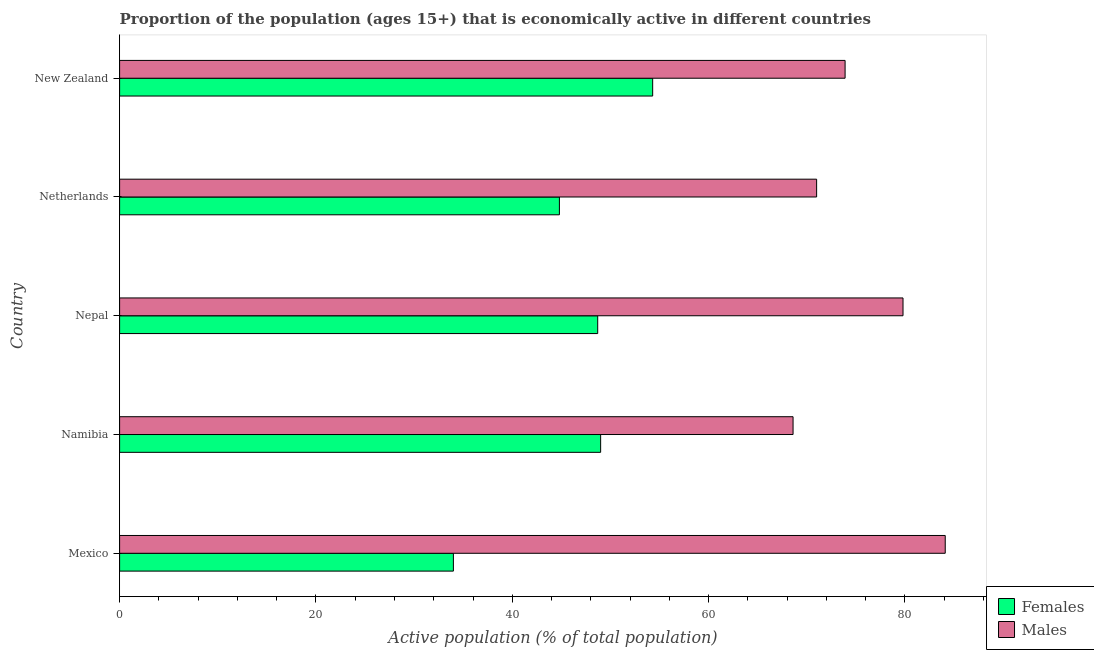How many different coloured bars are there?
Give a very brief answer. 2. Are the number of bars per tick equal to the number of legend labels?
Your answer should be very brief. Yes. Are the number of bars on each tick of the Y-axis equal?
Provide a short and direct response. Yes. How many bars are there on the 2nd tick from the top?
Provide a succinct answer. 2. What is the label of the 4th group of bars from the top?
Provide a succinct answer. Namibia. What is the percentage of economically active female population in New Zealand?
Ensure brevity in your answer.  54.3. Across all countries, what is the maximum percentage of economically active female population?
Make the answer very short. 54.3. Across all countries, what is the minimum percentage of economically active female population?
Your answer should be compact. 34. In which country was the percentage of economically active male population maximum?
Offer a very short reply. Mexico. In which country was the percentage of economically active male population minimum?
Provide a short and direct response. Namibia. What is the total percentage of economically active female population in the graph?
Offer a terse response. 230.8. What is the difference between the percentage of economically active female population in Netherlands and the percentage of economically active male population in Nepal?
Offer a very short reply. -35. What is the average percentage of economically active female population per country?
Your answer should be very brief. 46.16. What is the difference between the percentage of economically active male population and percentage of economically active female population in Namibia?
Offer a terse response. 19.6. What is the ratio of the percentage of economically active male population in Mexico to that in Namibia?
Provide a succinct answer. 1.23. Is the percentage of economically active female population in Netherlands less than that in New Zealand?
Offer a very short reply. Yes. Is the difference between the percentage of economically active female population in Mexico and New Zealand greater than the difference between the percentage of economically active male population in Mexico and New Zealand?
Ensure brevity in your answer.  No. What is the difference between the highest and the lowest percentage of economically active male population?
Your answer should be compact. 15.5. In how many countries, is the percentage of economically active male population greater than the average percentage of economically active male population taken over all countries?
Provide a succinct answer. 2. Is the sum of the percentage of economically active female population in Mexico and Netherlands greater than the maximum percentage of economically active male population across all countries?
Your response must be concise. No. What does the 1st bar from the top in Mexico represents?
Your answer should be very brief. Males. What does the 1st bar from the bottom in New Zealand represents?
Give a very brief answer. Females. How many bars are there?
Offer a very short reply. 10. Are all the bars in the graph horizontal?
Keep it short and to the point. Yes. Are the values on the major ticks of X-axis written in scientific E-notation?
Your answer should be very brief. No. Does the graph contain grids?
Offer a very short reply. No. Where does the legend appear in the graph?
Keep it short and to the point. Bottom right. What is the title of the graph?
Your answer should be compact. Proportion of the population (ages 15+) that is economically active in different countries. What is the label or title of the X-axis?
Offer a terse response. Active population (% of total population). What is the label or title of the Y-axis?
Offer a very short reply. Country. What is the Active population (% of total population) of Males in Mexico?
Provide a succinct answer. 84.1. What is the Active population (% of total population) of Males in Namibia?
Give a very brief answer. 68.6. What is the Active population (% of total population) of Females in Nepal?
Offer a very short reply. 48.7. What is the Active population (% of total population) in Males in Nepal?
Provide a succinct answer. 79.8. What is the Active population (% of total population) in Females in Netherlands?
Give a very brief answer. 44.8. What is the Active population (% of total population) of Females in New Zealand?
Provide a succinct answer. 54.3. What is the Active population (% of total population) in Males in New Zealand?
Keep it short and to the point. 73.9. Across all countries, what is the maximum Active population (% of total population) in Females?
Your response must be concise. 54.3. Across all countries, what is the maximum Active population (% of total population) in Males?
Offer a terse response. 84.1. Across all countries, what is the minimum Active population (% of total population) of Females?
Make the answer very short. 34. Across all countries, what is the minimum Active population (% of total population) in Males?
Your answer should be very brief. 68.6. What is the total Active population (% of total population) of Females in the graph?
Your response must be concise. 230.8. What is the total Active population (% of total population) in Males in the graph?
Your answer should be very brief. 377.4. What is the difference between the Active population (% of total population) of Females in Mexico and that in Namibia?
Offer a very short reply. -15. What is the difference between the Active population (% of total population) in Females in Mexico and that in Nepal?
Your response must be concise. -14.7. What is the difference between the Active population (% of total population) of Females in Mexico and that in Netherlands?
Your response must be concise. -10.8. What is the difference between the Active population (% of total population) of Females in Mexico and that in New Zealand?
Your answer should be compact. -20.3. What is the difference between the Active population (% of total population) of Males in Mexico and that in New Zealand?
Keep it short and to the point. 10.2. What is the difference between the Active population (% of total population) of Females in Namibia and that in Nepal?
Provide a succinct answer. 0.3. What is the difference between the Active population (% of total population) of Males in Namibia and that in Netherlands?
Your answer should be very brief. -2.4. What is the difference between the Active population (% of total population) of Males in Namibia and that in New Zealand?
Your answer should be compact. -5.3. What is the difference between the Active population (% of total population) in Females in Nepal and that in Netherlands?
Your answer should be compact. 3.9. What is the difference between the Active population (% of total population) of Males in Nepal and that in New Zealand?
Provide a short and direct response. 5.9. What is the difference between the Active population (% of total population) of Males in Netherlands and that in New Zealand?
Make the answer very short. -2.9. What is the difference between the Active population (% of total population) of Females in Mexico and the Active population (% of total population) of Males in Namibia?
Give a very brief answer. -34.6. What is the difference between the Active population (% of total population) of Females in Mexico and the Active population (% of total population) of Males in Nepal?
Offer a very short reply. -45.8. What is the difference between the Active population (% of total population) in Females in Mexico and the Active population (% of total population) in Males in Netherlands?
Your response must be concise. -37. What is the difference between the Active population (% of total population) in Females in Mexico and the Active population (% of total population) in Males in New Zealand?
Your answer should be very brief. -39.9. What is the difference between the Active population (% of total population) in Females in Namibia and the Active population (% of total population) in Males in Nepal?
Provide a succinct answer. -30.8. What is the difference between the Active population (% of total population) of Females in Namibia and the Active population (% of total population) of Males in New Zealand?
Your answer should be very brief. -24.9. What is the difference between the Active population (% of total population) of Females in Nepal and the Active population (% of total population) of Males in Netherlands?
Make the answer very short. -22.3. What is the difference between the Active population (% of total population) of Females in Nepal and the Active population (% of total population) of Males in New Zealand?
Provide a succinct answer. -25.2. What is the difference between the Active population (% of total population) in Females in Netherlands and the Active population (% of total population) in Males in New Zealand?
Give a very brief answer. -29.1. What is the average Active population (% of total population) of Females per country?
Provide a succinct answer. 46.16. What is the average Active population (% of total population) of Males per country?
Your answer should be very brief. 75.48. What is the difference between the Active population (% of total population) of Females and Active population (% of total population) of Males in Mexico?
Offer a terse response. -50.1. What is the difference between the Active population (% of total population) in Females and Active population (% of total population) in Males in Namibia?
Offer a very short reply. -19.6. What is the difference between the Active population (% of total population) of Females and Active population (% of total population) of Males in Nepal?
Give a very brief answer. -31.1. What is the difference between the Active population (% of total population) in Females and Active population (% of total population) in Males in Netherlands?
Your answer should be compact. -26.2. What is the difference between the Active population (% of total population) of Females and Active population (% of total population) of Males in New Zealand?
Give a very brief answer. -19.6. What is the ratio of the Active population (% of total population) in Females in Mexico to that in Namibia?
Ensure brevity in your answer.  0.69. What is the ratio of the Active population (% of total population) of Males in Mexico to that in Namibia?
Ensure brevity in your answer.  1.23. What is the ratio of the Active population (% of total population) of Females in Mexico to that in Nepal?
Provide a short and direct response. 0.7. What is the ratio of the Active population (% of total population) in Males in Mexico to that in Nepal?
Give a very brief answer. 1.05. What is the ratio of the Active population (% of total population) in Females in Mexico to that in Netherlands?
Keep it short and to the point. 0.76. What is the ratio of the Active population (% of total population) of Males in Mexico to that in Netherlands?
Offer a very short reply. 1.18. What is the ratio of the Active population (% of total population) of Females in Mexico to that in New Zealand?
Your response must be concise. 0.63. What is the ratio of the Active population (% of total population) in Males in Mexico to that in New Zealand?
Ensure brevity in your answer.  1.14. What is the ratio of the Active population (% of total population) in Males in Namibia to that in Nepal?
Keep it short and to the point. 0.86. What is the ratio of the Active population (% of total population) in Females in Namibia to that in Netherlands?
Give a very brief answer. 1.09. What is the ratio of the Active population (% of total population) of Males in Namibia to that in Netherlands?
Ensure brevity in your answer.  0.97. What is the ratio of the Active population (% of total population) of Females in Namibia to that in New Zealand?
Offer a terse response. 0.9. What is the ratio of the Active population (% of total population) in Males in Namibia to that in New Zealand?
Provide a succinct answer. 0.93. What is the ratio of the Active population (% of total population) in Females in Nepal to that in Netherlands?
Make the answer very short. 1.09. What is the ratio of the Active population (% of total population) in Males in Nepal to that in Netherlands?
Ensure brevity in your answer.  1.12. What is the ratio of the Active population (% of total population) of Females in Nepal to that in New Zealand?
Your response must be concise. 0.9. What is the ratio of the Active population (% of total population) of Males in Nepal to that in New Zealand?
Offer a very short reply. 1.08. What is the ratio of the Active population (% of total population) of Females in Netherlands to that in New Zealand?
Give a very brief answer. 0.82. What is the ratio of the Active population (% of total population) in Males in Netherlands to that in New Zealand?
Offer a terse response. 0.96. What is the difference between the highest and the lowest Active population (% of total population) of Females?
Provide a short and direct response. 20.3. What is the difference between the highest and the lowest Active population (% of total population) in Males?
Keep it short and to the point. 15.5. 